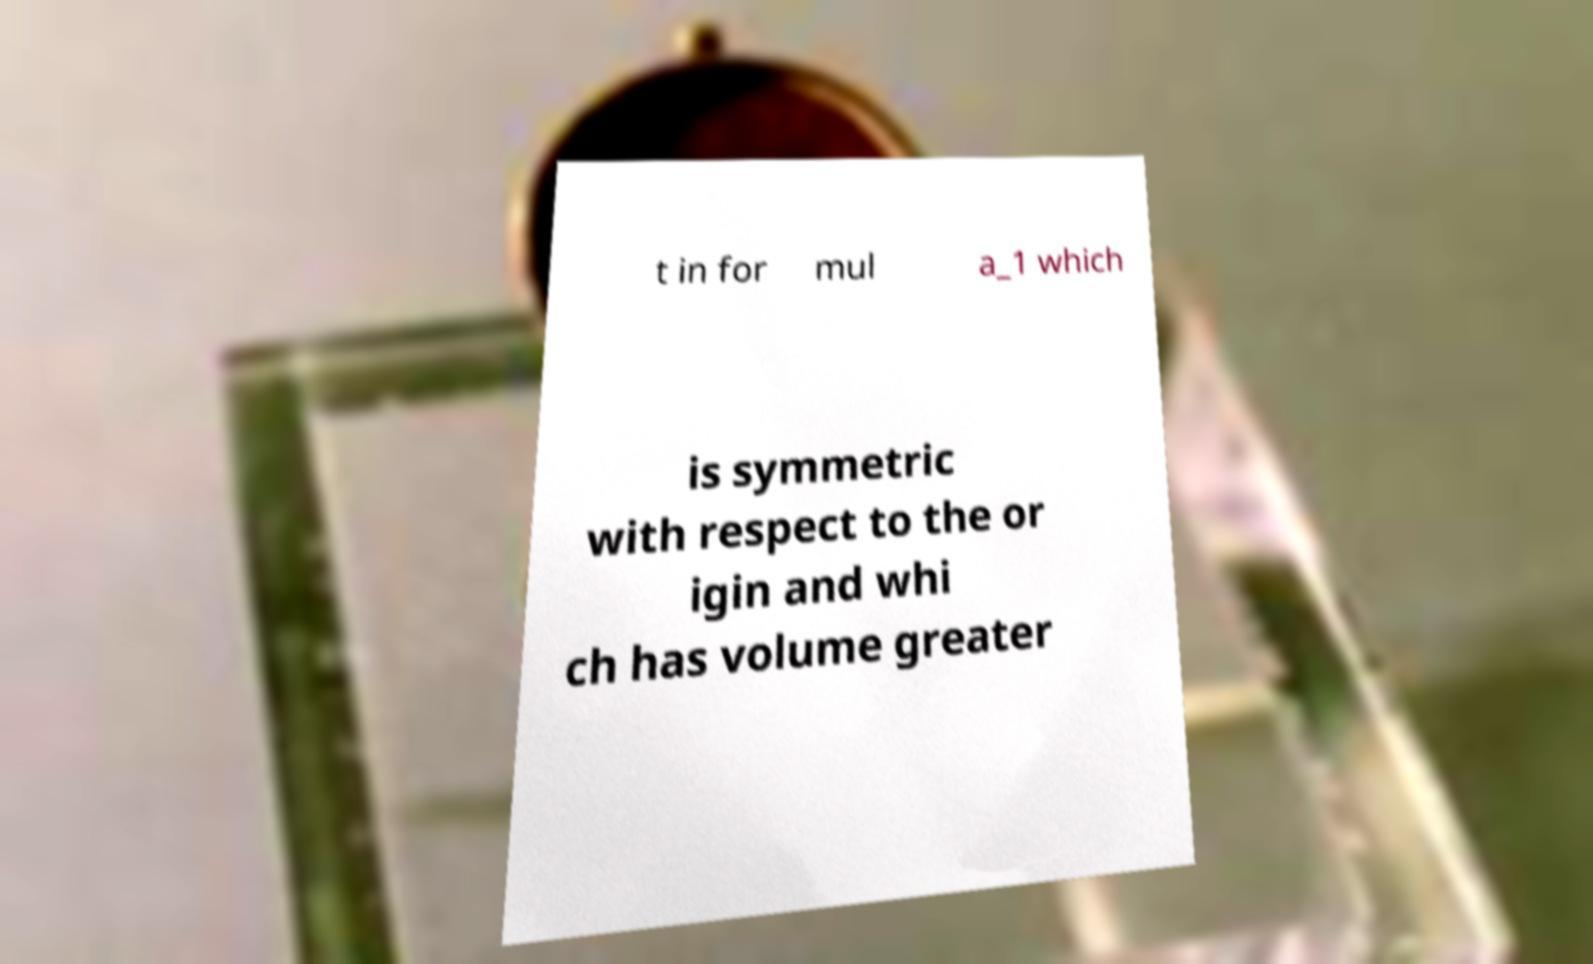Please identify and transcribe the text found in this image. t in for mul a_1 which is symmetric with respect to the or igin and whi ch has volume greater 